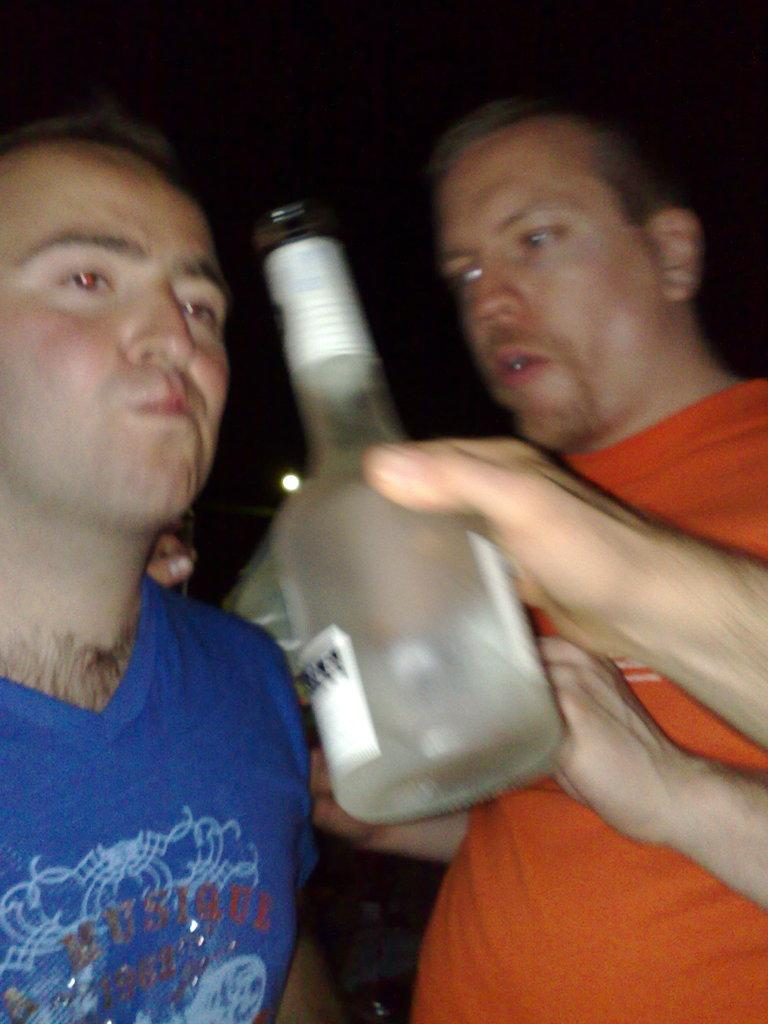What is the main object in the center of the image? There is a bottle in the center of the image. Who are the people in the image? There are two men in the image, one in an orange dress on the right side and another in a blue dress on the left side. What can be said about the appearance of the men in the image? Both men are stunning. How would you describe the background of the image? The background of the image is dark. What type of game is being played in the image? There is no game being played in the image; it features a bottle and two men in stunning dresses. Can you see any ghosts in the image? There are no ghosts present in the image. 